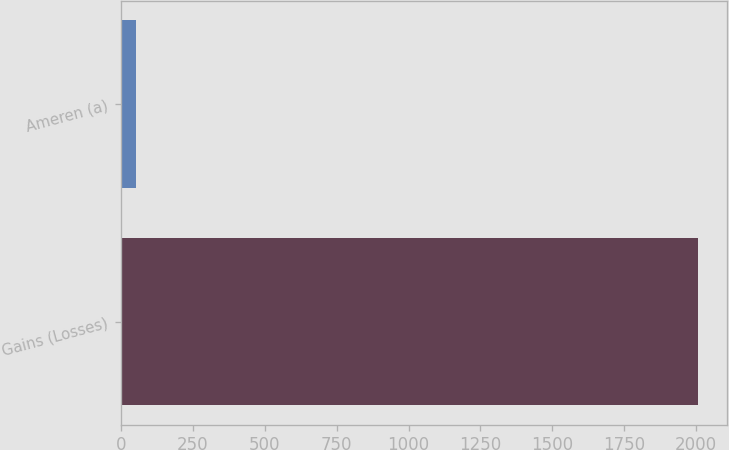Convert chart to OTSL. <chart><loc_0><loc_0><loc_500><loc_500><bar_chart><fcel>Gains (Losses)<fcel>Ameren (a)<nl><fcel>2008<fcel>53<nl></chart> 